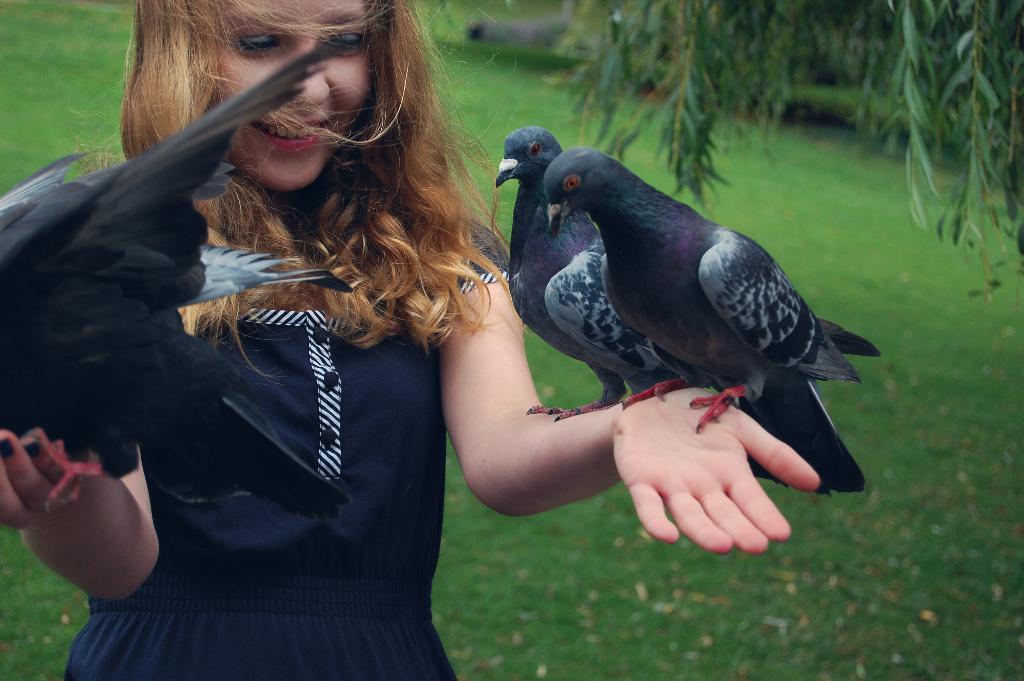In one or two sentences, can you explain what this image depicts? In this image, I can see a girl with birds and she is standing and smiling. In the background, I can see the grass and a tree. 